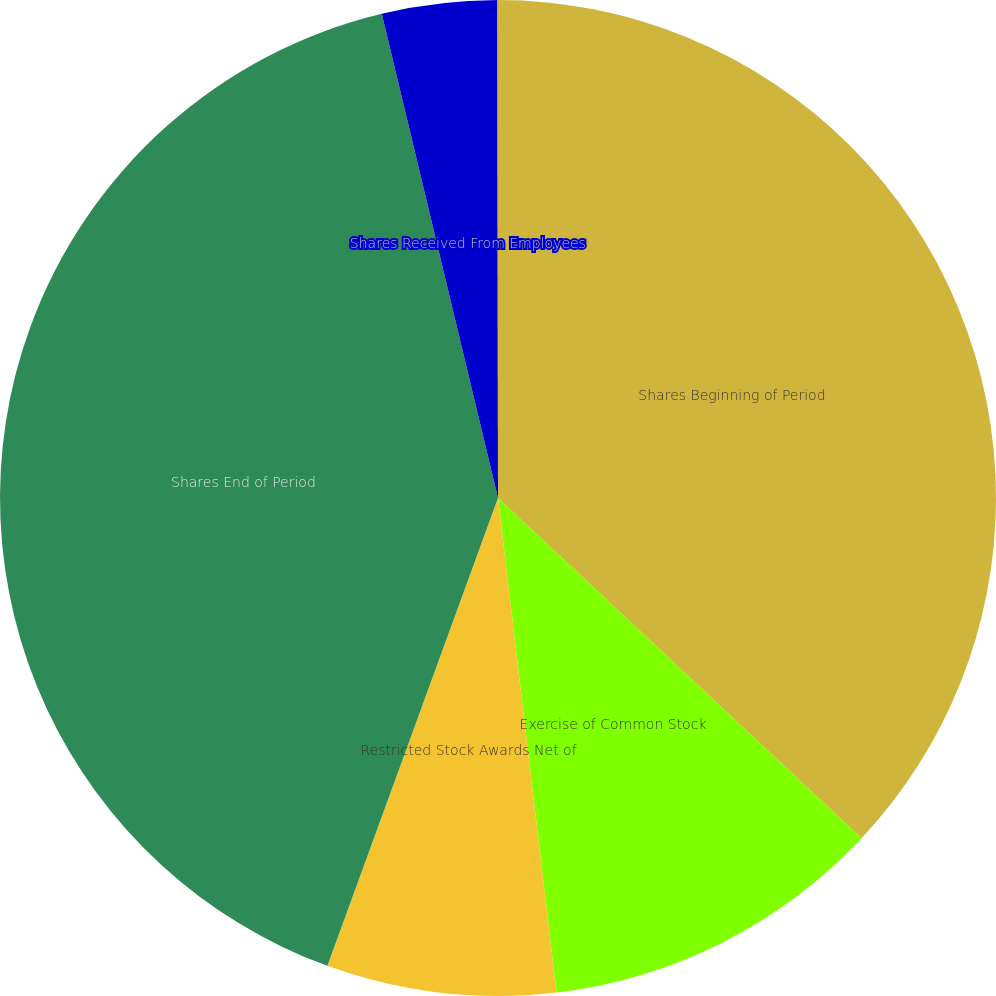<chart> <loc_0><loc_0><loc_500><loc_500><pie_chart><fcel>Shares Beginning of Period<fcel>Exercise of Common Stock<fcel>Restricted Stock Awards Net of<fcel>Shares End of Period<fcel>Shares Received From Employees<fcel>Rabbi Trust Shares Distributed<nl><fcel>36.98%<fcel>11.15%<fcel>7.44%<fcel>40.69%<fcel>3.73%<fcel>0.02%<nl></chart> 